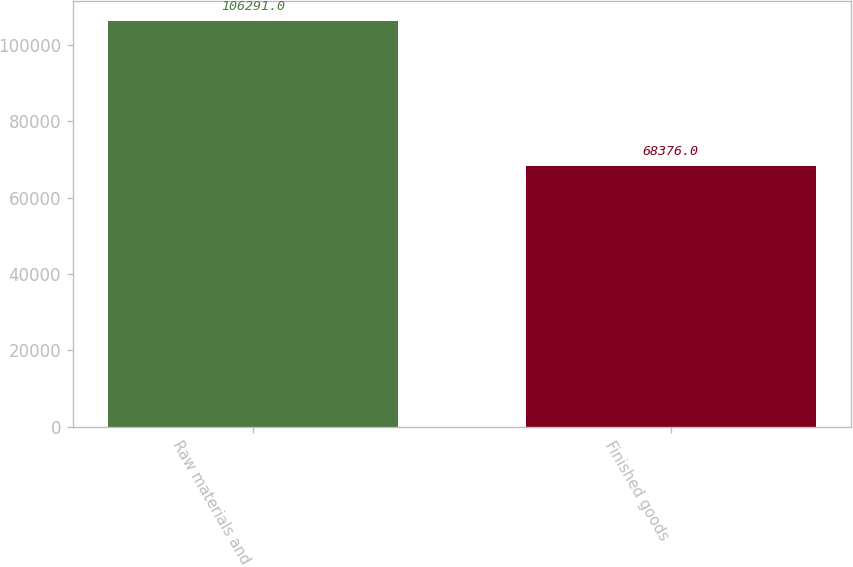Convert chart. <chart><loc_0><loc_0><loc_500><loc_500><bar_chart><fcel>Raw materials and<fcel>Finished goods<nl><fcel>106291<fcel>68376<nl></chart> 